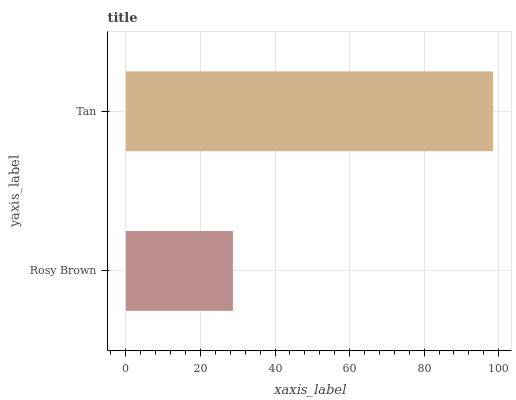Is Rosy Brown the minimum?
Answer yes or no. Yes. Is Tan the maximum?
Answer yes or no. Yes. Is Tan the minimum?
Answer yes or no. No. Is Tan greater than Rosy Brown?
Answer yes or no. Yes. Is Rosy Brown less than Tan?
Answer yes or no. Yes. Is Rosy Brown greater than Tan?
Answer yes or no. No. Is Tan less than Rosy Brown?
Answer yes or no. No. Is Tan the high median?
Answer yes or no. Yes. Is Rosy Brown the low median?
Answer yes or no. Yes. Is Rosy Brown the high median?
Answer yes or no. No. Is Tan the low median?
Answer yes or no. No. 